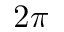<formula> <loc_0><loc_0><loc_500><loc_500>2 \pi</formula> 